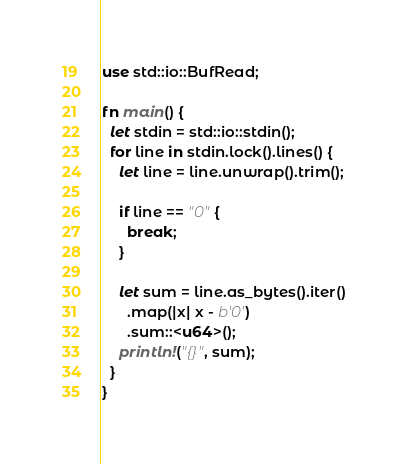<code> <loc_0><loc_0><loc_500><loc_500><_Rust_>use std::io::BufRead;

fn main() {
  let stdin = std::io::stdin();
  for line in stdin.lock().lines() {
    let line = line.unwrap().trim();

    if line == "0" {
      break;
    }
    
    let sum = line.as_bytes().iter()
      .map(|x| x - b'0')
      .sum::<u64>();
    println!("{}", sum);
  }
}
</code> 